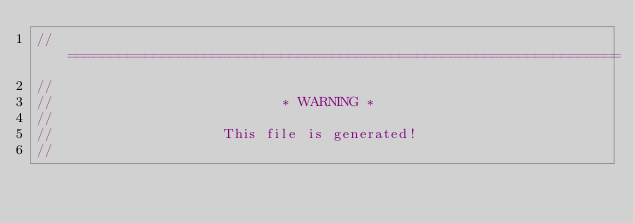<code> <loc_0><loc_0><loc_500><loc_500><_Rust_>// =================================================================
//
//                           * WARNING *
//
//                    This file is generated!
//</code> 